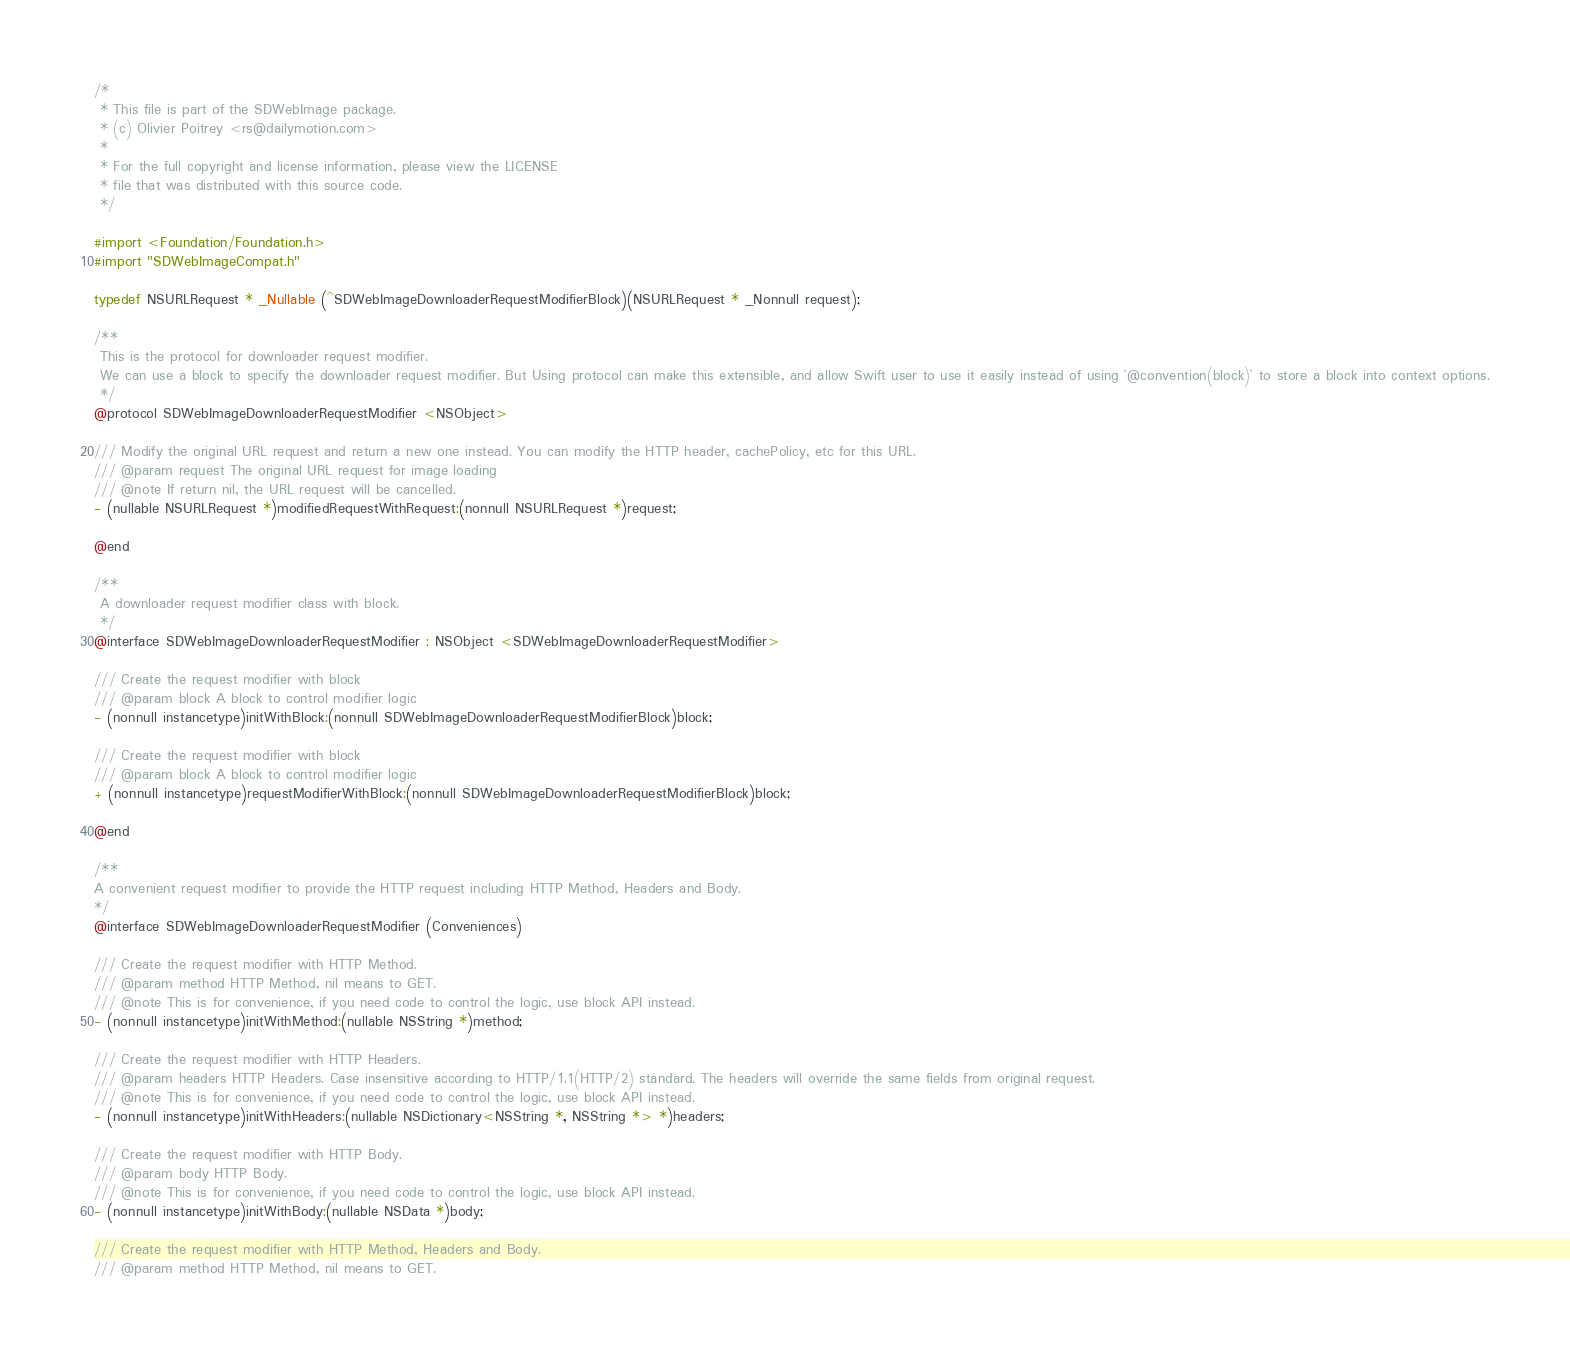<code> <loc_0><loc_0><loc_500><loc_500><_C_>/*
 * This file is part of the SDWebImage package.
 * (c) Olivier Poitrey <rs@dailymotion.com>
 *
 * For the full copyright and license information, please view the LICENSE
 * file that was distributed with this source code.
 */

#import <Foundation/Foundation.h>
#import "SDWebImageCompat.h"

typedef NSURLRequest * _Nullable (^SDWebImageDownloaderRequestModifierBlock)(NSURLRequest * _Nonnull request);

/**
 This is the protocol for downloader request modifier.
 We can use a block to specify the downloader request modifier. But Using protocol can make this extensible, and allow Swift user to use it easily instead of using `@convention(block)` to store a block into context options.
 */
@protocol SDWebImageDownloaderRequestModifier <NSObject>

/// Modify the original URL request and return a new one instead. You can modify the HTTP header, cachePolicy, etc for this URL.
/// @param request The original URL request for image loading
/// @note If return nil, the URL request will be cancelled.
- (nullable NSURLRequest *)modifiedRequestWithRequest:(nonnull NSURLRequest *)request;

@end

/**
 A downloader request modifier class with block.
 */
@interface SDWebImageDownloaderRequestModifier : NSObject <SDWebImageDownloaderRequestModifier>

/// Create the request modifier with block
/// @param block A block to control modifier logic
- (nonnull instancetype)initWithBlock:(nonnull SDWebImageDownloaderRequestModifierBlock)block;

/// Create the request modifier with block
/// @param block A block to control modifier logic
+ (nonnull instancetype)requestModifierWithBlock:(nonnull SDWebImageDownloaderRequestModifierBlock)block;

@end

/**
A convenient request modifier to provide the HTTP request including HTTP Method, Headers and Body.
*/
@interface SDWebImageDownloaderRequestModifier (Conveniences)

/// Create the request modifier with HTTP Method.
/// @param method HTTP Method, nil means to GET.
/// @note This is for convenience, if you need code to control the logic, use block API instead.
- (nonnull instancetype)initWithMethod:(nullable NSString *)method;

/// Create the request modifier with HTTP Headers.
/// @param headers HTTP Headers. Case insensitive according to HTTP/1.1(HTTP/2) standard. The headers will override the same fields from original request.
/// @note This is for convenience, if you need code to control the logic, use block API instead.
- (nonnull instancetype)initWithHeaders:(nullable NSDictionary<NSString *, NSString *> *)headers;

/// Create the request modifier with HTTP Body.
/// @param body HTTP Body.
/// @note This is for convenience, if you need code to control the logic, use block API instead.
- (nonnull instancetype)initWithBody:(nullable NSData *)body;

/// Create the request modifier with HTTP Method, Headers and Body.
/// @param method HTTP Method, nil means to GET.</code> 